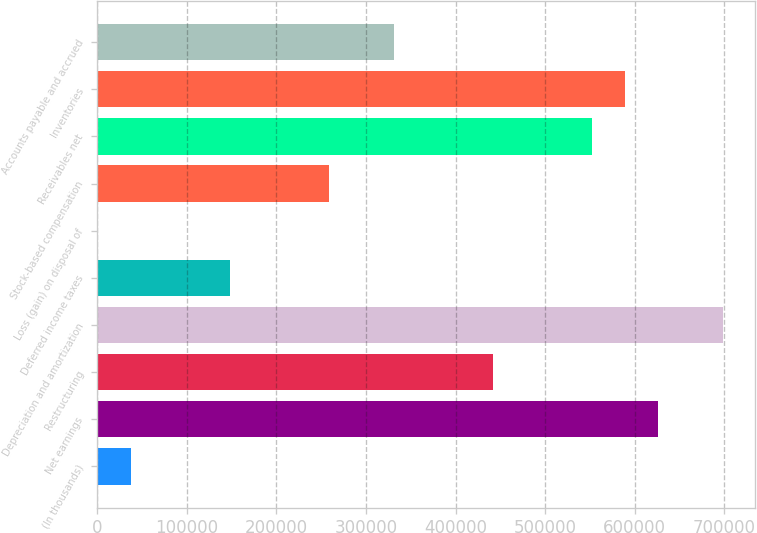Convert chart to OTSL. <chart><loc_0><loc_0><loc_500><loc_500><bar_chart><fcel>(In thousands)<fcel>Net earnings<fcel>Restructuring<fcel>Depreciation and amortization<fcel>Deferred income taxes<fcel>Loss (gain) on disposal of<fcel>Stock-based compensation<fcel>Receivables net<fcel>Inventories<fcel>Accounts payable and accrued<nl><fcel>37993.5<fcel>625522<fcel>441919<fcel>698962<fcel>148155<fcel>1273<fcel>258316<fcel>552080<fcel>588801<fcel>331758<nl></chart> 